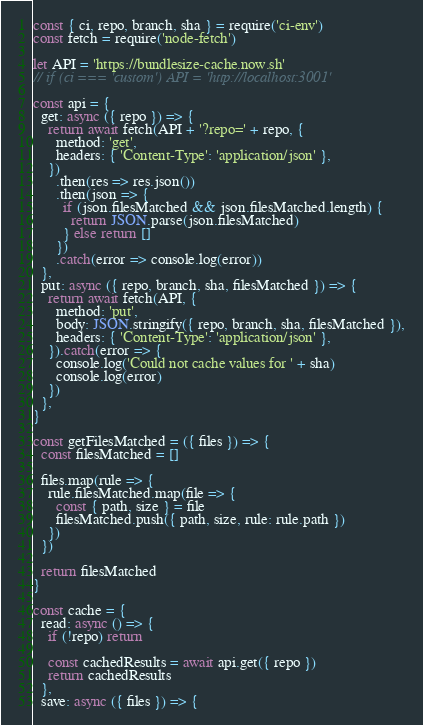Convert code to text. <code><loc_0><loc_0><loc_500><loc_500><_JavaScript_>const { ci, repo, branch, sha } = require('ci-env')
const fetch = require('node-fetch')

let API = 'https://bundlesize-cache.now.sh'
// if (ci === 'custom') API = 'http://localhost:3001'

const api = {
  get: async ({ repo }) => {
    return await fetch(API + '?repo=' + repo, {
      method: 'get',
      headers: { 'Content-Type': 'application/json' },
    })
      .then(res => res.json())
      .then(json => {
        if (json.filesMatched && json.filesMatched.length) {
          return JSON.parse(json.filesMatched)
        } else return []
      })
      .catch(error => console.log(error))
  },
  put: async ({ repo, branch, sha, filesMatched }) => {
    return await fetch(API, {
      method: 'put',
      body: JSON.stringify({ repo, branch, sha, filesMatched }),
      headers: { 'Content-Type': 'application/json' },
    }).catch(error => {
      console.log('Could not cache values for ' + sha)
      console.log(error)
    })
  },
}

const getFilesMatched = ({ files }) => {
  const filesMatched = []

  files.map(rule => {
    rule.filesMatched.map(file => {
      const { path, size } = file
      filesMatched.push({ path, size, rule: rule.path })
    })
  })

  return filesMatched
}

const cache = {
  read: async () => {
    if (!repo) return

    const cachedResults = await api.get({ repo })
    return cachedResults
  },
  save: async ({ files }) => {</code> 